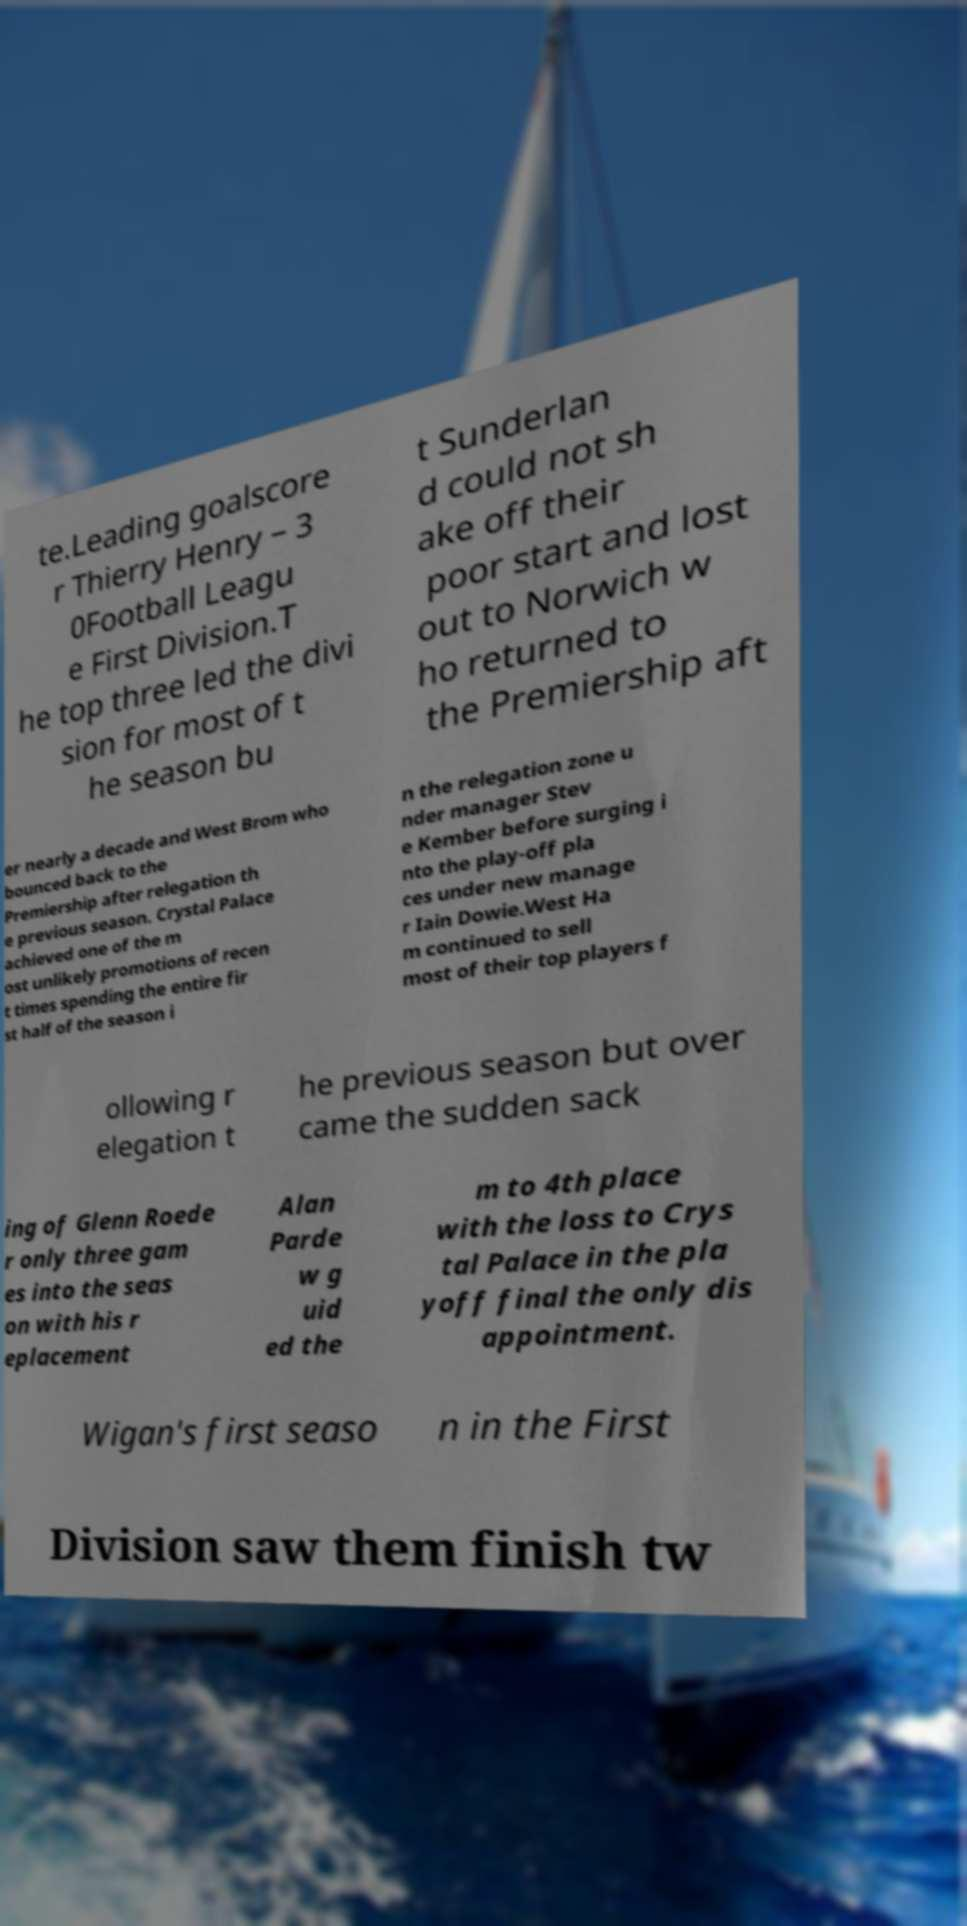For documentation purposes, I need the text within this image transcribed. Could you provide that? te.Leading goalscore r Thierry Henry – 3 0Football Leagu e First Division.T he top three led the divi sion for most of t he season bu t Sunderlan d could not sh ake off their poor start and lost out to Norwich w ho returned to the Premiership aft er nearly a decade and West Brom who bounced back to the Premiership after relegation th e previous season. Crystal Palace achieved one of the m ost unlikely promotions of recen t times spending the entire fir st half of the season i n the relegation zone u nder manager Stev e Kember before surging i nto the play-off pla ces under new manage r Iain Dowie.West Ha m continued to sell most of their top players f ollowing r elegation t he previous season but over came the sudden sack ing of Glenn Roede r only three gam es into the seas on with his r eplacement Alan Parde w g uid ed the m to 4th place with the loss to Crys tal Palace in the pla yoff final the only dis appointment. Wigan's first seaso n in the First Division saw them finish tw 